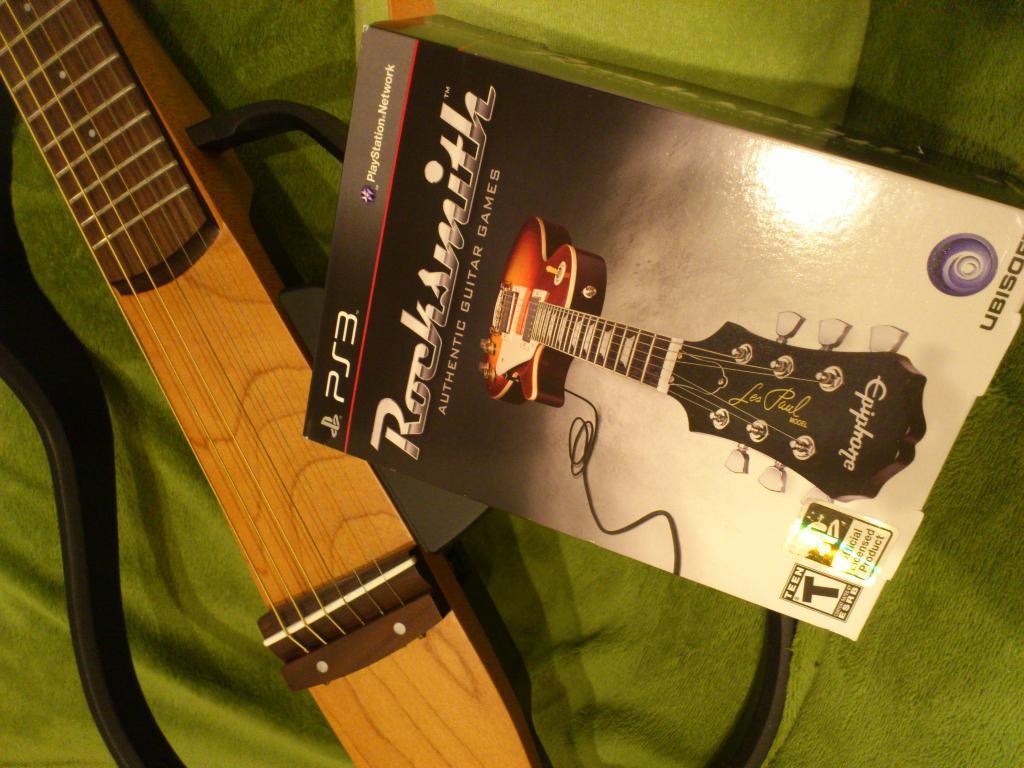In one or two sentences, can you explain what this image depicts? In this image i can see a box and a guitar. 